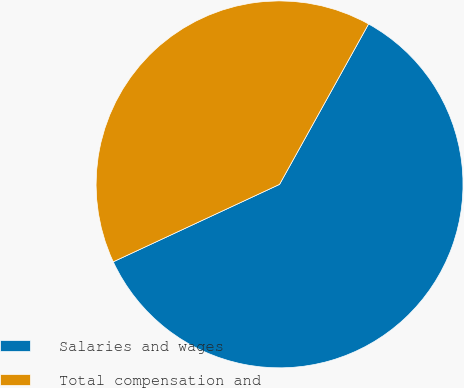Convert chart. <chart><loc_0><loc_0><loc_500><loc_500><pie_chart><fcel>Salaries and wages<fcel>Total compensation and<nl><fcel>60.0%<fcel>40.0%<nl></chart> 